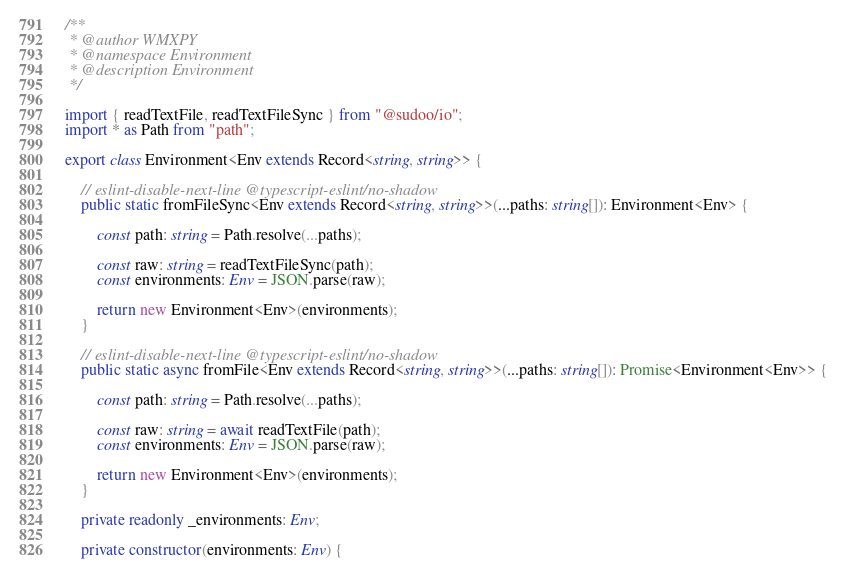Convert code to text. <code><loc_0><loc_0><loc_500><loc_500><_TypeScript_>/**
 * @author WMXPY
 * @namespace Environment
 * @description Environment
 */

import { readTextFile, readTextFileSync } from "@sudoo/io";
import * as Path from "path";

export class Environment<Env extends Record<string, string>> {

    // eslint-disable-next-line @typescript-eslint/no-shadow
    public static fromFileSync<Env extends Record<string, string>>(...paths: string[]): Environment<Env> {

        const path: string = Path.resolve(...paths);

        const raw: string = readTextFileSync(path);
        const environments: Env = JSON.parse(raw);

        return new Environment<Env>(environments);
    }

    // eslint-disable-next-line @typescript-eslint/no-shadow
    public static async fromFile<Env extends Record<string, string>>(...paths: string[]): Promise<Environment<Env>> {

        const path: string = Path.resolve(...paths);

        const raw: string = await readTextFile(path);
        const environments: Env = JSON.parse(raw);

        return new Environment<Env>(environments);
    }

    private readonly _environments: Env;

    private constructor(environments: Env) {
</code> 